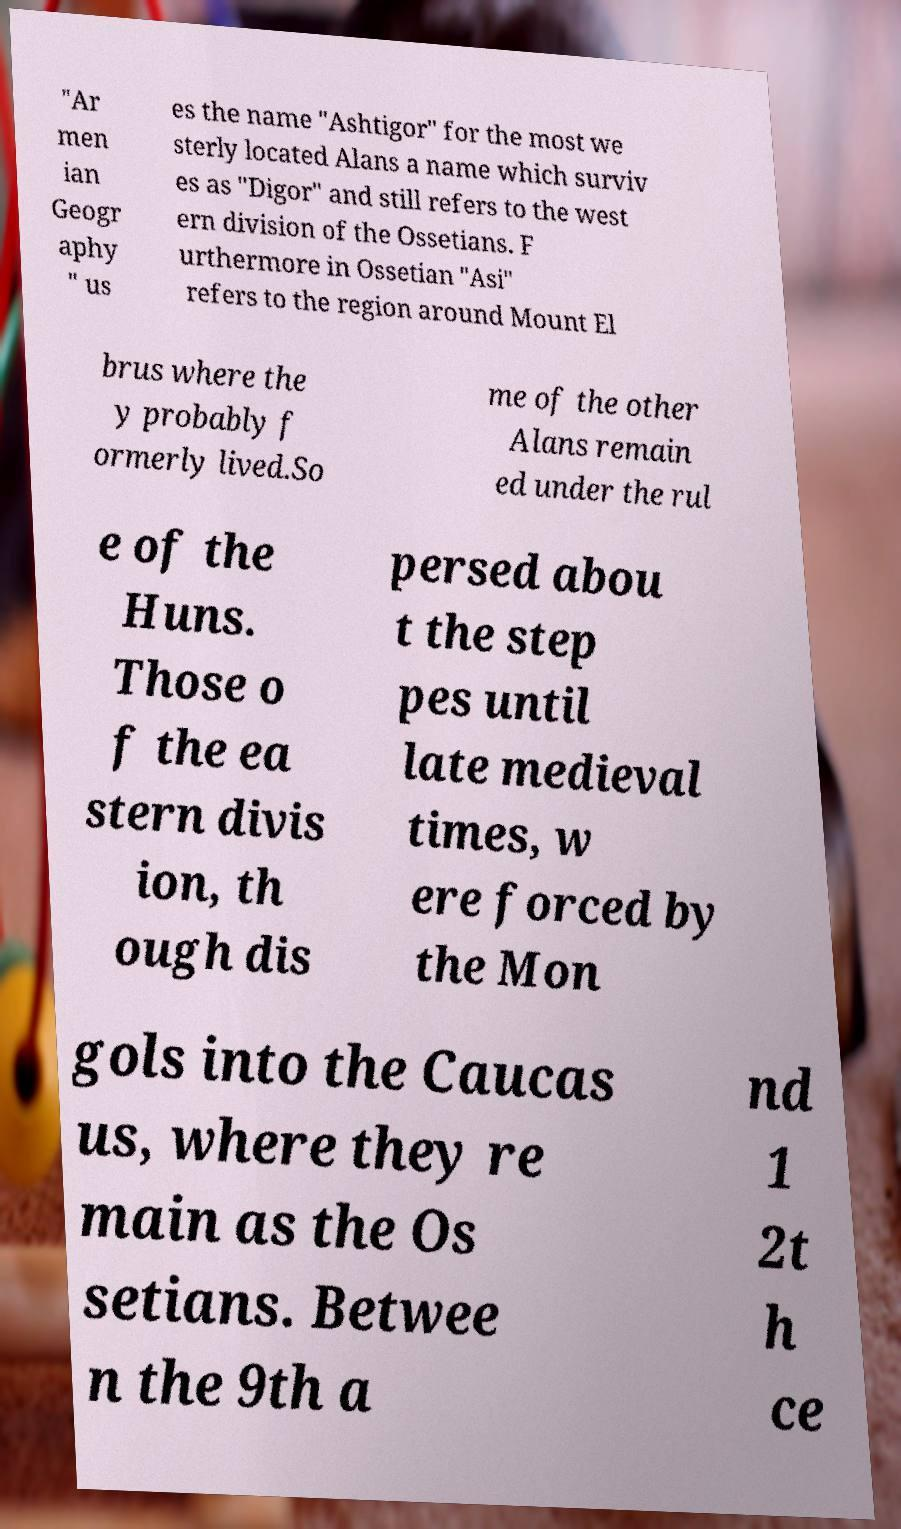Please identify and transcribe the text found in this image. "Ar men ian Geogr aphy " us es the name "Ashtigor" for the most we sterly located Alans a name which surviv es as "Digor" and still refers to the west ern division of the Ossetians. F urthermore in Ossetian "Asi" refers to the region around Mount El brus where the y probably f ormerly lived.So me of the other Alans remain ed under the rul e of the Huns. Those o f the ea stern divis ion, th ough dis persed abou t the step pes until late medieval times, w ere forced by the Mon gols into the Caucas us, where they re main as the Os setians. Betwee n the 9th a nd 1 2t h ce 